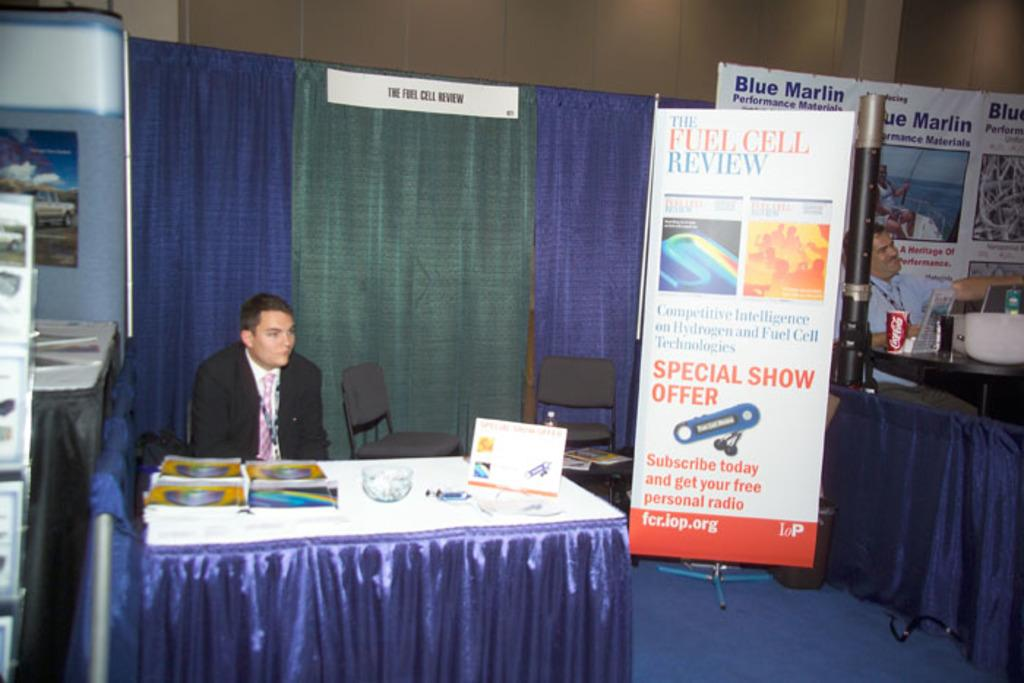<image>
Give a short and clear explanation of the subsequent image. A person standing near the Fuel Cell Review banner. 